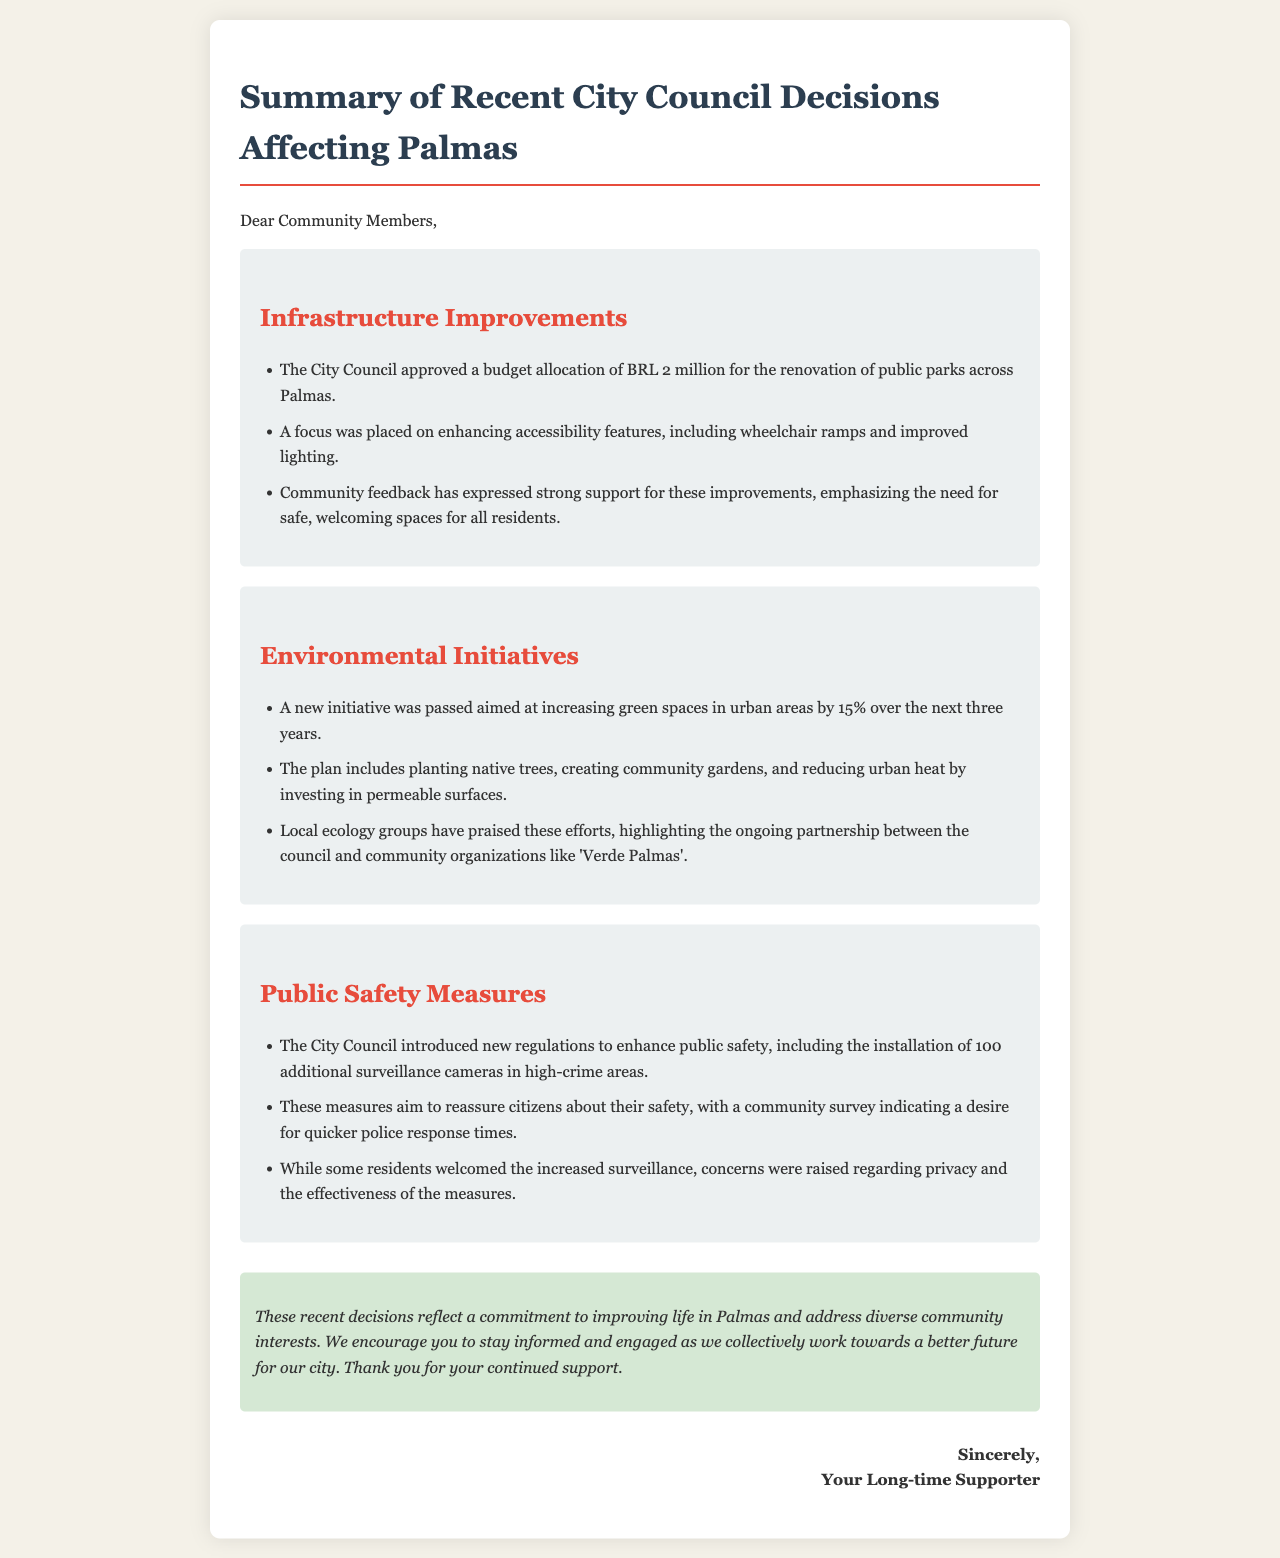What is the budget allocation for public parks renovation? The document states that the City Council approved a budget allocation of BRL 2 million for the renovation of public parks across Palmas.
Answer: BRL 2 million What percentage increase in green spaces is the initiative aiming for? The document mentions that the plan aims to increase green spaces in urban areas by 15% over the next three years.
Answer: 15% How many surveillance cameras are to be installed? According to the document, the City Council introduced the installation of 100 additional surveillance cameras in high-crime areas.
Answer: 100 Which community organization is mentioned in relation to the environmental initiatives? The document highlights the partnership between the council and community organizations, specifically naming 'Verde Palmas'.
Answer: Verde Palmas What is one concern raised by residents regarding public safety measures? The document states that while some residents welcomed increased surveillance, concerns were raised about privacy.
Answer: Privacy What key feature was emphasized in the public parks renovation? The document indicates a focus on enhancing accessibility features, including wheelchair ramps.
Answer: Wheelchair ramps What is the conclusion of the document? The conclusion reflects the commitment to improving life in Palmas and encourages the community to stay informed and engaged.
Answer: Commitment to improving life in Palmas What type of feedback was received regarding infrastructure improvements? The document notes that community feedback expressed strong support for the improvements.
Answer: Strong support 